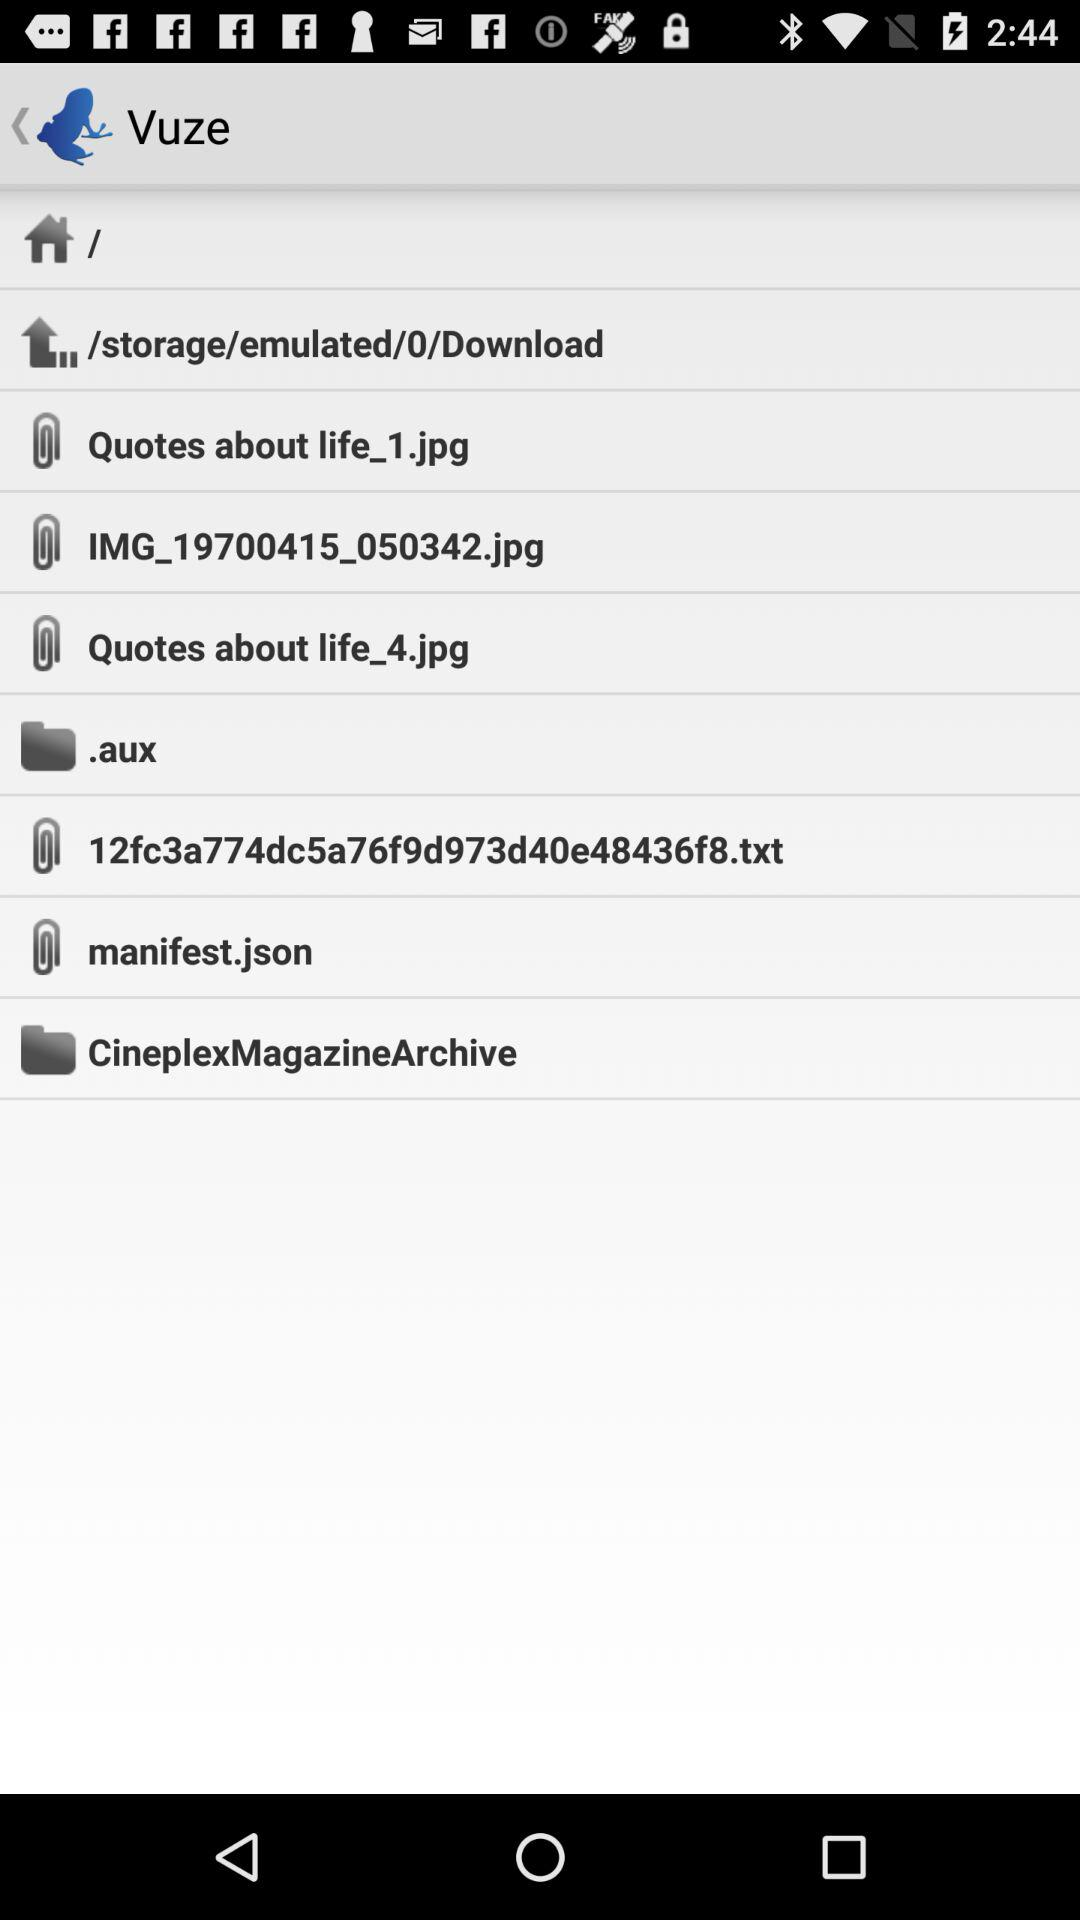How many items have a file extension?
Answer the question using a single word or phrase. 5 